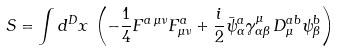Convert formula to latex. <formula><loc_0><loc_0><loc_500><loc_500>S = \int d ^ { D } x \, \left ( - \frac { 1 } { 4 } F ^ { a \, \mu \nu } F ^ { a } _ { \mu \nu } + \frac { i } { 2 } \bar { \psi } ^ { a } _ { \alpha } \gamma ^ { \mu } _ { \alpha \beta } \, D ^ { a b } _ { \mu } \psi ^ { b } _ { \beta } \right )</formula> 